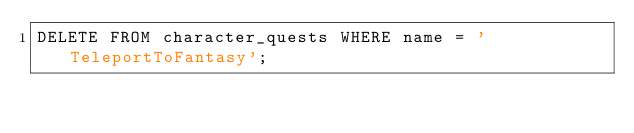Convert code to text. <code><loc_0><loc_0><loc_500><loc_500><_SQL_>DELETE FROM character_quests WHERE name = 'TeleportToFantasy';</code> 